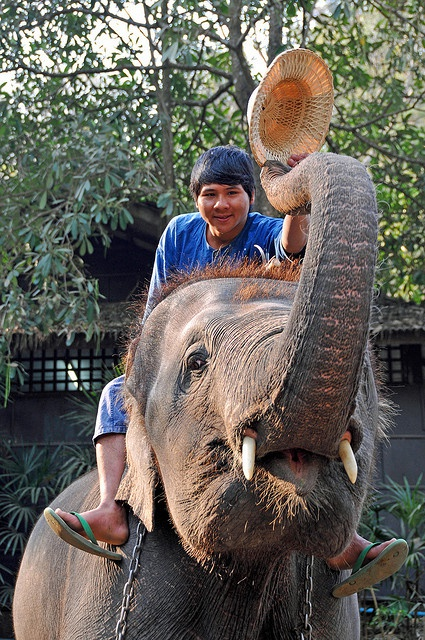Describe the objects in this image and their specific colors. I can see elephant in white, black, gray, darkgray, and tan tones and people in white, black, brown, maroon, and darkgray tones in this image. 